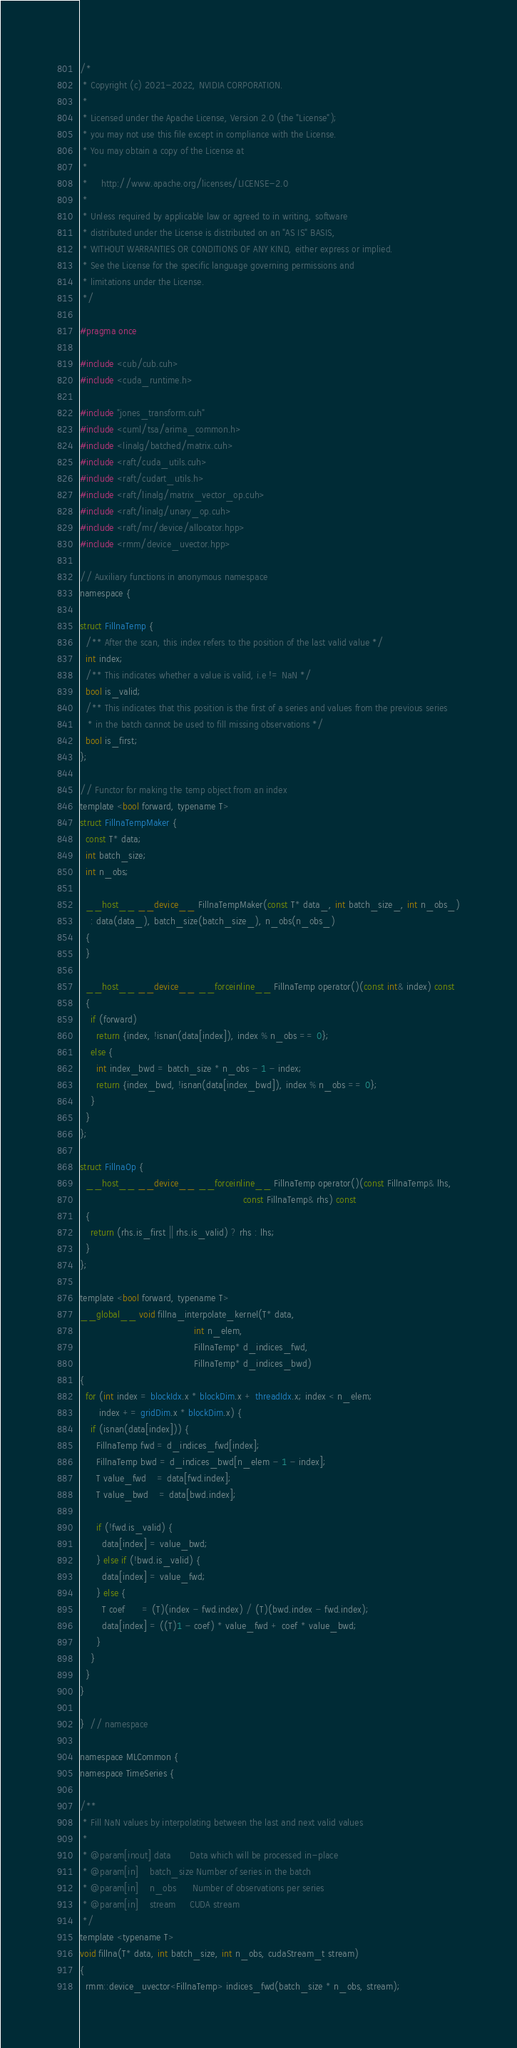<code> <loc_0><loc_0><loc_500><loc_500><_Cuda_>/*
 * Copyright (c) 2021-2022, NVIDIA CORPORATION.
 *
 * Licensed under the Apache License, Version 2.0 (the "License");
 * you may not use this file except in compliance with the License.
 * You may obtain a copy of the License at
 *
 *     http://www.apache.org/licenses/LICENSE-2.0
 *
 * Unless required by applicable law or agreed to in writing, software
 * distributed under the License is distributed on an "AS IS" BASIS,
 * WITHOUT WARRANTIES OR CONDITIONS OF ANY KIND, either express or implied.
 * See the License for the specific language governing permissions and
 * limitations under the License.
 */

#pragma once

#include <cub/cub.cuh>
#include <cuda_runtime.h>

#include "jones_transform.cuh"
#include <cuml/tsa/arima_common.h>
#include <linalg/batched/matrix.cuh>
#include <raft/cuda_utils.cuh>
#include <raft/cudart_utils.h>
#include <raft/linalg/matrix_vector_op.cuh>
#include <raft/linalg/unary_op.cuh>
#include <raft/mr/device/allocator.hpp>
#include <rmm/device_uvector.hpp>

// Auxiliary functions in anonymous namespace
namespace {

struct FillnaTemp {
  /** After the scan, this index refers to the position of the last valid value */
  int index;
  /** This indicates whether a value is valid, i.e != NaN */
  bool is_valid;
  /** This indicates that this position is the first of a series and values from the previous series
   * in the batch cannot be used to fill missing observations */
  bool is_first;
};

// Functor for making the temp object from an index
template <bool forward, typename T>
struct FillnaTempMaker {
  const T* data;
  int batch_size;
  int n_obs;

  __host__ __device__ FillnaTempMaker(const T* data_, int batch_size_, int n_obs_)
    : data(data_), batch_size(batch_size_), n_obs(n_obs_)
  {
  }

  __host__ __device__ __forceinline__ FillnaTemp operator()(const int& index) const
  {
    if (forward)
      return {index, !isnan(data[index]), index % n_obs == 0};
    else {
      int index_bwd = batch_size * n_obs - 1 - index;
      return {index_bwd, !isnan(data[index_bwd]), index % n_obs == 0};
    }
  }
};

struct FillnaOp {
  __host__ __device__ __forceinline__ FillnaTemp operator()(const FillnaTemp& lhs,
                                                            const FillnaTemp& rhs) const
  {
    return (rhs.is_first || rhs.is_valid) ? rhs : lhs;
  }
};

template <bool forward, typename T>
__global__ void fillna_interpolate_kernel(T* data,
                                          int n_elem,
                                          FillnaTemp* d_indices_fwd,
                                          FillnaTemp* d_indices_bwd)
{
  for (int index = blockIdx.x * blockDim.x + threadIdx.x; index < n_elem;
       index += gridDim.x * blockDim.x) {
    if (isnan(data[index])) {
      FillnaTemp fwd = d_indices_fwd[index];
      FillnaTemp bwd = d_indices_bwd[n_elem - 1 - index];
      T value_fwd    = data[fwd.index];
      T value_bwd    = data[bwd.index];

      if (!fwd.is_valid) {
        data[index] = value_bwd;
      } else if (!bwd.is_valid) {
        data[index] = value_fwd;
      } else {
        T coef      = (T)(index - fwd.index) / (T)(bwd.index - fwd.index);
        data[index] = ((T)1 - coef) * value_fwd + coef * value_bwd;
      }
    }
  }
}

}  // namespace

namespace MLCommon {
namespace TimeSeries {

/**
 * Fill NaN values by interpolating between the last and next valid values
 *
 * @param[inout] data       Data which will be processed in-place
 * @param[in]    batch_size Number of series in the batch
 * @param[in]    n_obs      Number of observations per series
 * @param[in]    stream     CUDA stream
 */
template <typename T>
void fillna(T* data, int batch_size, int n_obs, cudaStream_t stream)
{
  rmm::device_uvector<FillnaTemp> indices_fwd(batch_size * n_obs, stream);</code> 